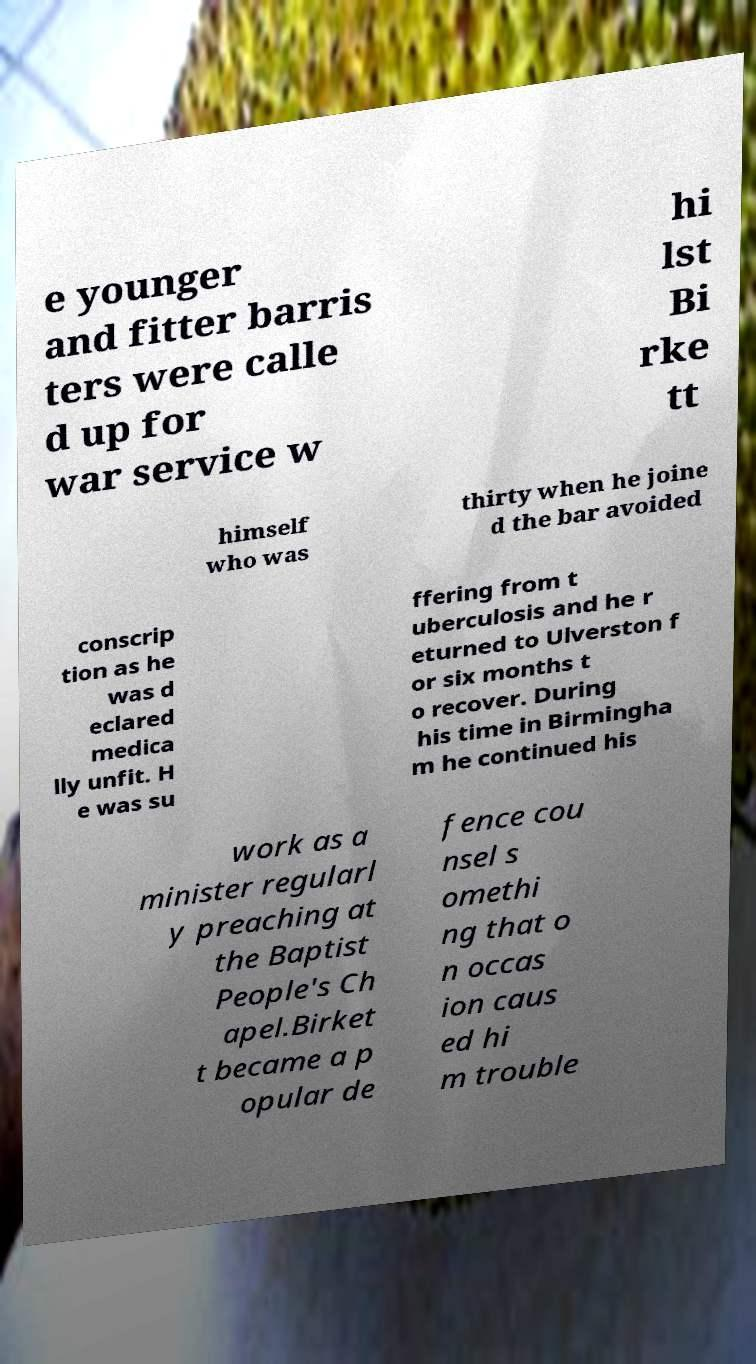I need the written content from this picture converted into text. Can you do that? e younger and fitter barris ters were calle d up for war service w hi lst Bi rke tt himself who was thirty when he joine d the bar avoided conscrip tion as he was d eclared medica lly unfit. H e was su ffering from t uberculosis and he r eturned to Ulverston f or six months t o recover. During his time in Birmingha m he continued his work as a minister regularl y preaching at the Baptist People's Ch apel.Birket t became a p opular de fence cou nsel s omethi ng that o n occas ion caus ed hi m trouble 